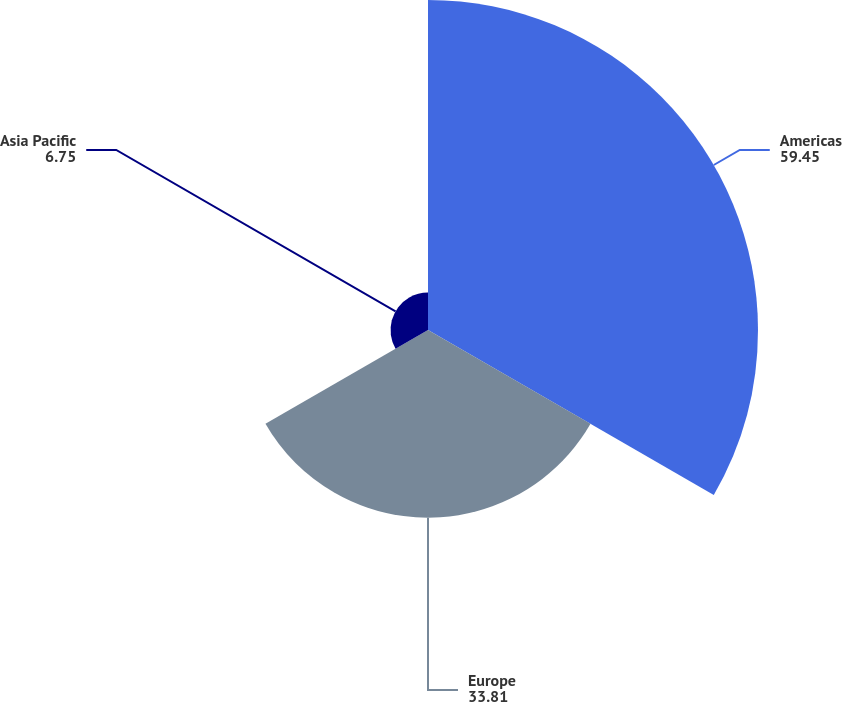<chart> <loc_0><loc_0><loc_500><loc_500><pie_chart><fcel>Americas<fcel>Europe<fcel>Asia Pacific<nl><fcel>59.45%<fcel>33.81%<fcel>6.75%<nl></chart> 